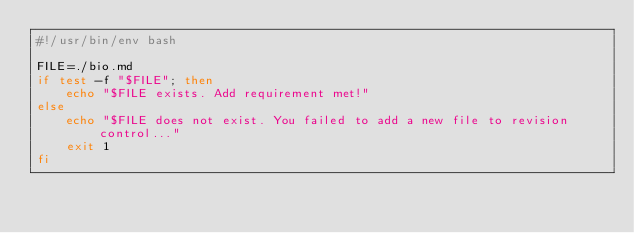Convert code to text. <code><loc_0><loc_0><loc_500><loc_500><_Bash_>#!/usr/bin/env bash

FILE=./bio.md
if test -f "$FILE"; then
    echo "$FILE exists. Add requirement met!"
else
    echo "$FILE does not exist. You failed to add a new file to revision control..."
    exit 1
fi
</code> 